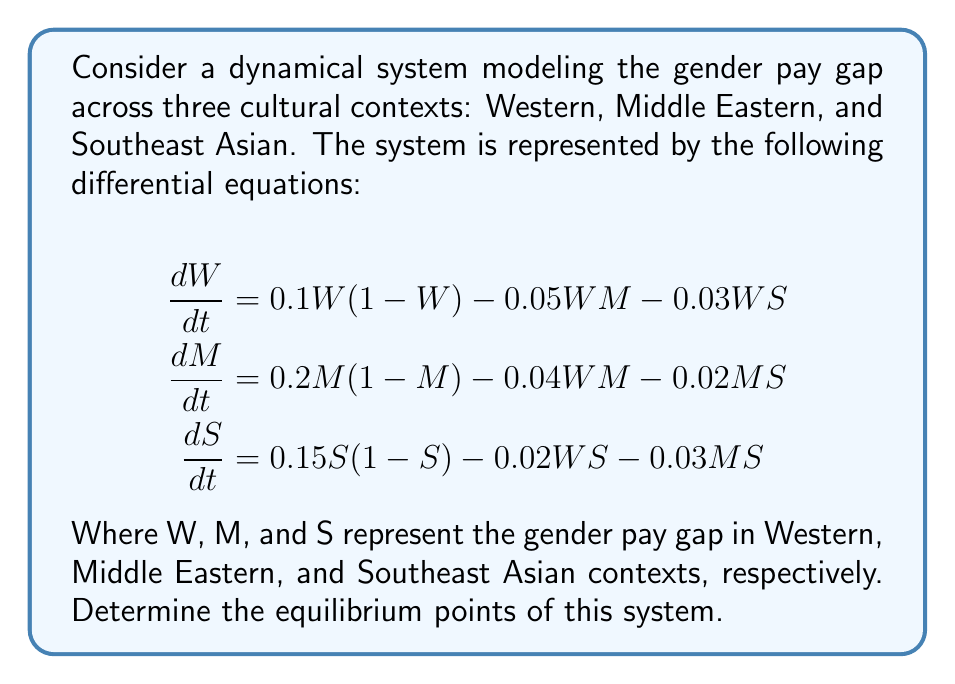Can you answer this question? To find the equilibrium points, we need to set each differential equation to zero and solve the resulting system of equations:

1) Set each equation to zero:
   $$\begin{align}
   0.1W(1-W) - 0.05WM - 0.03WS &= 0 \\
   0.2M(1-M) - 0.04WM - 0.02MS &= 0 \\
   0.15S(1-S) - 0.02WS - 0.03MS &= 0
   \end{align}$$

2) Factor out W, M, and S from each equation:
   $$\begin{align}
   W(0.1 - 0.1W - 0.05M - 0.03S) &= 0 \\
   M(0.2 - 0.2M - 0.04W - 0.02S) &= 0 \\
   S(0.15 - 0.15S - 0.02W - 0.03M) &= 0
   \end{align}$$

3) From these equations, we can see that one equilibrium point is (0, 0, 0), representing no gender pay gap in all contexts.

4) For non-zero equilibrium points, we need to solve:
   $$\begin{align}
   0.1 - 0.1W - 0.05M - 0.03S &= 0 \\
   0.2 - 0.2M - 0.04W - 0.02S &= 0 \\
   0.15 - 0.15S - 0.02W - 0.03M &= 0
   \end{align}$$

5) This system of linear equations can be solved using substitution or matrix methods. The solution is:
   $$W \approx 0.8095, M \approx 0.9048, S \approx 0.8571$$

Therefore, there are two equilibrium points: (0, 0, 0) and (0.8095, 0.9048, 0.8571).
Answer: (0, 0, 0) and (0.8095, 0.9048, 0.8571) 